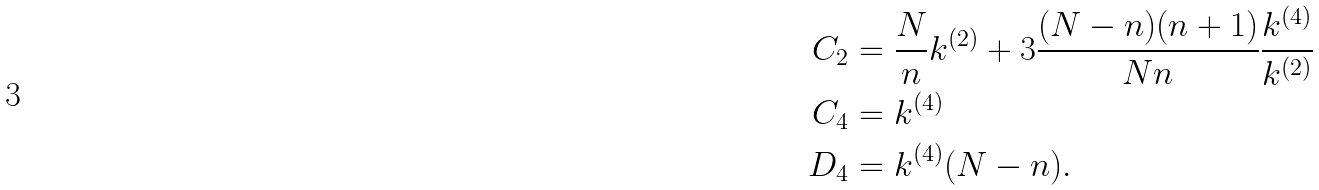Convert formula to latex. <formula><loc_0><loc_0><loc_500><loc_500>C _ { 2 } & = \frac { N } { n } k ^ { ( 2 ) } + 3 \frac { ( N - n ) ( n + 1 ) } { N n } \frac { k ^ { ( 4 ) } } { k ^ { ( 2 ) } } \\ C _ { 4 } & = k ^ { ( 4 ) } \\ D _ { 4 } & = k ^ { ( 4 ) } ( N - n ) .</formula> 